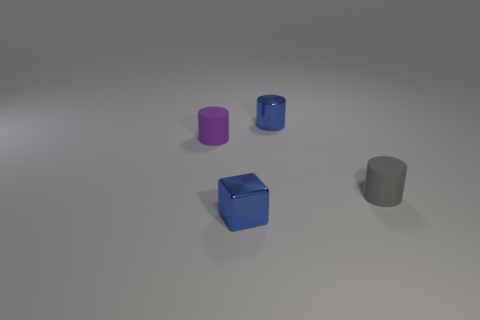What number of metal objects are in front of the gray cylinder?
Give a very brief answer. 1. What size is the purple cylinder?
Your answer should be compact. Small. There is another object that is the same material as the purple object; what color is it?
Ensure brevity in your answer.  Gray. How many blocks are the same size as the blue cylinder?
Provide a short and direct response. 1. Is the thing that is in front of the tiny gray rubber cylinder made of the same material as the small blue cylinder?
Your answer should be compact. Yes. Are there fewer things on the right side of the blue block than blue objects?
Keep it short and to the point. No. There is a matte thing that is behind the gray rubber cylinder; what is its shape?
Offer a terse response. Cylinder. What is the shape of the blue object that is the same size as the metallic block?
Your answer should be compact. Cylinder. Is there another tiny rubber thing of the same shape as the tiny purple matte thing?
Provide a short and direct response. Yes. Is the shape of the rubber object that is in front of the purple thing the same as the rubber object that is on the left side of the gray rubber thing?
Your response must be concise. Yes. 